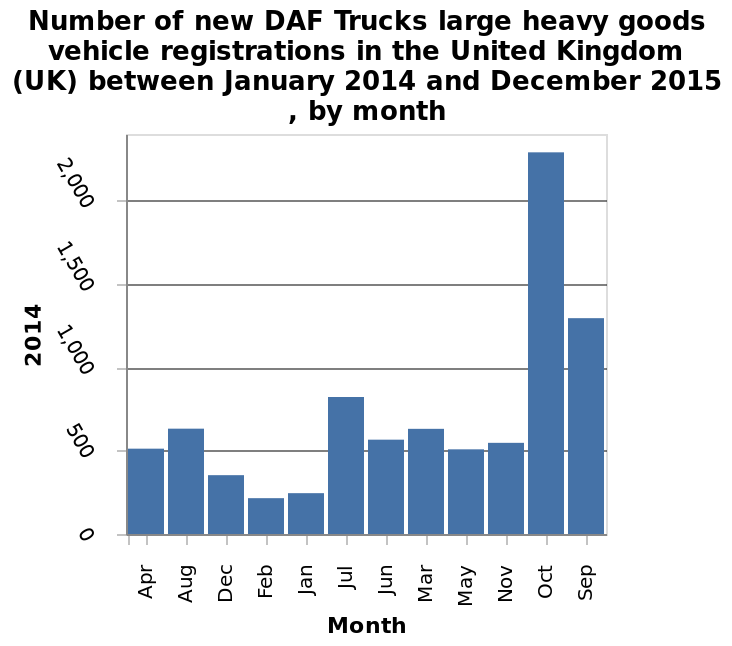<image>
please enumerates aspects of the construction of the chart Here a bar graph is named Number of new DAF Trucks large heavy goods vehicle registrations in the United Kingdom (UK) between January 2014 and December 2015 , by month. The x-axis plots Month with categorical scale starting at Apr and ending at  while the y-axis measures 2014 using linear scale of range 0 to 2,000. Which months have the lowest number of new DAF truck registrations? The months with the lowest number of new DAF truck registrations are December, January, and February. What time period does the bar graph cover? The bar graph covers the period between January 2014 and December 2015. 